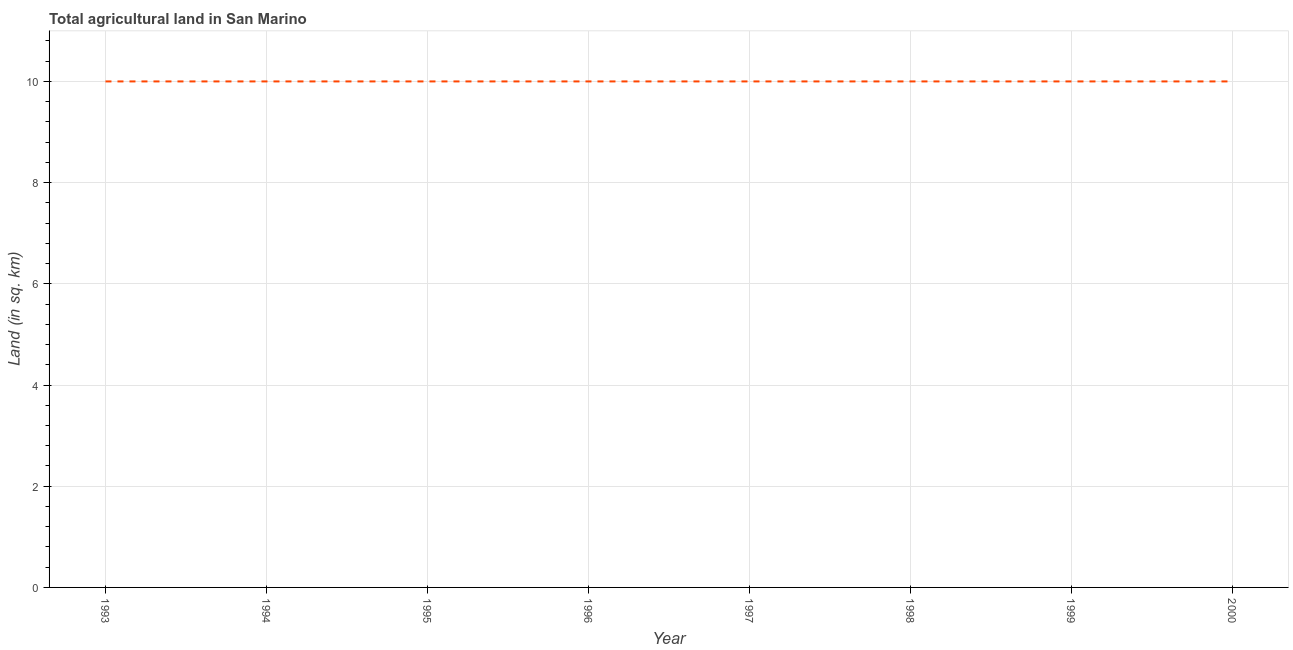What is the agricultural land in 2000?
Ensure brevity in your answer.  10. Across all years, what is the maximum agricultural land?
Provide a short and direct response. 10. Across all years, what is the minimum agricultural land?
Provide a succinct answer. 10. What is the sum of the agricultural land?
Your answer should be very brief. 80. What is the difference between the agricultural land in 1998 and 1999?
Your answer should be very brief. 0. Do a majority of the years between 1998 and 2000 (inclusive) have agricultural land greater than 10.4 sq. km?
Ensure brevity in your answer.  No. Is the agricultural land in 1998 less than that in 1999?
Your answer should be compact. No. Is the difference between the agricultural land in 1997 and 1999 greater than the difference between any two years?
Your answer should be very brief. Yes. Is the sum of the agricultural land in 1993 and 2000 greater than the maximum agricultural land across all years?
Your answer should be very brief. Yes. What is the difference between the highest and the lowest agricultural land?
Offer a terse response. 0. In how many years, is the agricultural land greater than the average agricultural land taken over all years?
Your answer should be very brief. 0. Does the agricultural land monotonically increase over the years?
Provide a succinct answer. No. How many years are there in the graph?
Give a very brief answer. 8. What is the difference between two consecutive major ticks on the Y-axis?
Your response must be concise. 2. What is the title of the graph?
Ensure brevity in your answer.  Total agricultural land in San Marino. What is the label or title of the Y-axis?
Offer a terse response. Land (in sq. km). What is the Land (in sq. km) in 1994?
Provide a succinct answer. 10. What is the Land (in sq. km) of 1996?
Provide a short and direct response. 10. What is the Land (in sq. km) in 1998?
Ensure brevity in your answer.  10. What is the Land (in sq. km) in 1999?
Provide a short and direct response. 10. What is the difference between the Land (in sq. km) in 1993 and 1995?
Your response must be concise. 0. What is the difference between the Land (in sq. km) in 1993 and 1998?
Give a very brief answer. 0. What is the difference between the Land (in sq. km) in 1994 and 1996?
Offer a very short reply. 0. What is the difference between the Land (in sq. km) in 1994 and 2000?
Your response must be concise. 0. What is the difference between the Land (in sq. km) in 1995 and 1996?
Your answer should be very brief. 0. What is the difference between the Land (in sq. km) in 1995 and 1997?
Make the answer very short. 0. What is the difference between the Land (in sq. km) in 1996 and 1997?
Offer a terse response. 0. What is the difference between the Land (in sq. km) in 1996 and 1998?
Offer a terse response. 0. What is the difference between the Land (in sq. km) in 1997 and 1998?
Keep it short and to the point. 0. What is the difference between the Land (in sq. km) in 1997 and 1999?
Provide a short and direct response. 0. What is the difference between the Land (in sq. km) in 1997 and 2000?
Your answer should be very brief. 0. What is the difference between the Land (in sq. km) in 1998 and 1999?
Keep it short and to the point. 0. What is the ratio of the Land (in sq. km) in 1993 to that in 1994?
Keep it short and to the point. 1. What is the ratio of the Land (in sq. km) in 1993 to that in 1995?
Offer a terse response. 1. What is the ratio of the Land (in sq. km) in 1993 to that in 1996?
Offer a terse response. 1. What is the ratio of the Land (in sq. km) in 1993 to that in 1997?
Give a very brief answer. 1. What is the ratio of the Land (in sq. km) in 1993 to that in 1998?
Offer a very short reply. 1. What is the ratio of the Land (in sq. km) in 1994 to that in 1996?
Provide a succinct answer. 1. What is the ratio of the Land (in sq. km) in 1994 to that in 1997?
Provide a short and direct response. 1. What is the ratio of the Land (in sq. km) in 1994 to that in 1999?
Offer a terse response. 1. What is the ratio of the Land (in sq. km) in 1994 to that in 2000?
Your response must be concise. 1. What is the ratio of the Land (in sq. km) in 1995 to that in 1997?
Provide a short and direct response. 1. What is the ratio of the Land (in sq. km) in 1995 to that in 1998?
Your answer should be very brief. 1. What is the ratio of the Land (in sq. km) in 1995 to that in 2000?
Your answer should be compact. 1. What is the ratio of the Land (in sq. km) in 1997 to that in 1999?
Your answer should be compact. 1. What is the ratio of the Land (in sq. km) in 1997 to that in 2000?
Provide a succinct answer. 1. What is the ratio of the Land (in sq. km) in 1998 to that in 1999?
Provide a short and direct response. 1. What is the ratio of the Land (in sq. km) in 1998 to that in 2000?
Provide a short and direct response. 1. What is the ratio of the Land (in sq. km) in 1999 to that in 2000?
Your answer should be very brief. 1. 